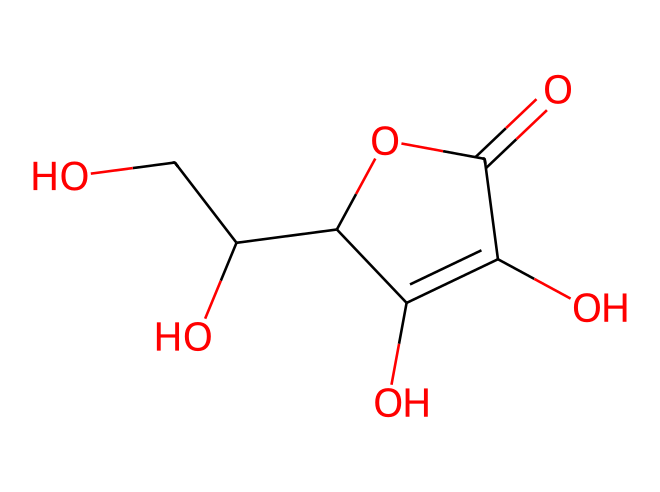how many carbon atoms are in ascorbic acid? The structural formula contains the notation for carbon atoms. Counting the carbon atoms from the SMILES representation reveals there are six carbon atoms present.
Answer: six how many hydroxyl (–OH) groups are present in the structure? By examining the chemical structure, we can see that there are four hydroxyl groups (–OH) attached to different carbon atoms.
Answer: four what is the molecular formula of vitamin C? The molecular formula can be deduced from the structure’s components: C6H8O6. This indicates it has six carbon atoms, eight hydrogen atoms, and six oxygen atoms.
Answer: C6H8O6 which functional group is present in the structure? Looking at the SMILES and the structure, we identify that the hydroxyl (–OH) groups are characteristic of alcohol functional groups. Additionally, the presence of a carboxylic acid (–COOH) is visible. Therefore, both alcohol and carboxylic acid functional groups can be identified.
Answer: alcohol, carboxylic acid what type of antioxidant is ascorbic acid classified as? Considering the structure and its properties, ascorbic acid (vitamin C) is classified as a water-soluble antioxidant due to its soluble nature in water and its role in scavenging free radicals.
Answer: water-soluble how does the structure of vitamin C contribute to its antioxidant properties? The presence of multiple hydroxyl groups provides ascorbic acid with the ability to donate electrons, which is a key feature of antioxidants. This capability allows it to neutralize free radicals effectively, thus contributing to its antioxidant properties.
Answer: electron donor how many double bonds does the structure contain? The structure reveals only one double bond between carbon and oxygen in the carbonyl group and a double bond between two carbon atoms in a cyclic structure. Therefore, there are two double bonds present.
Answer: two 